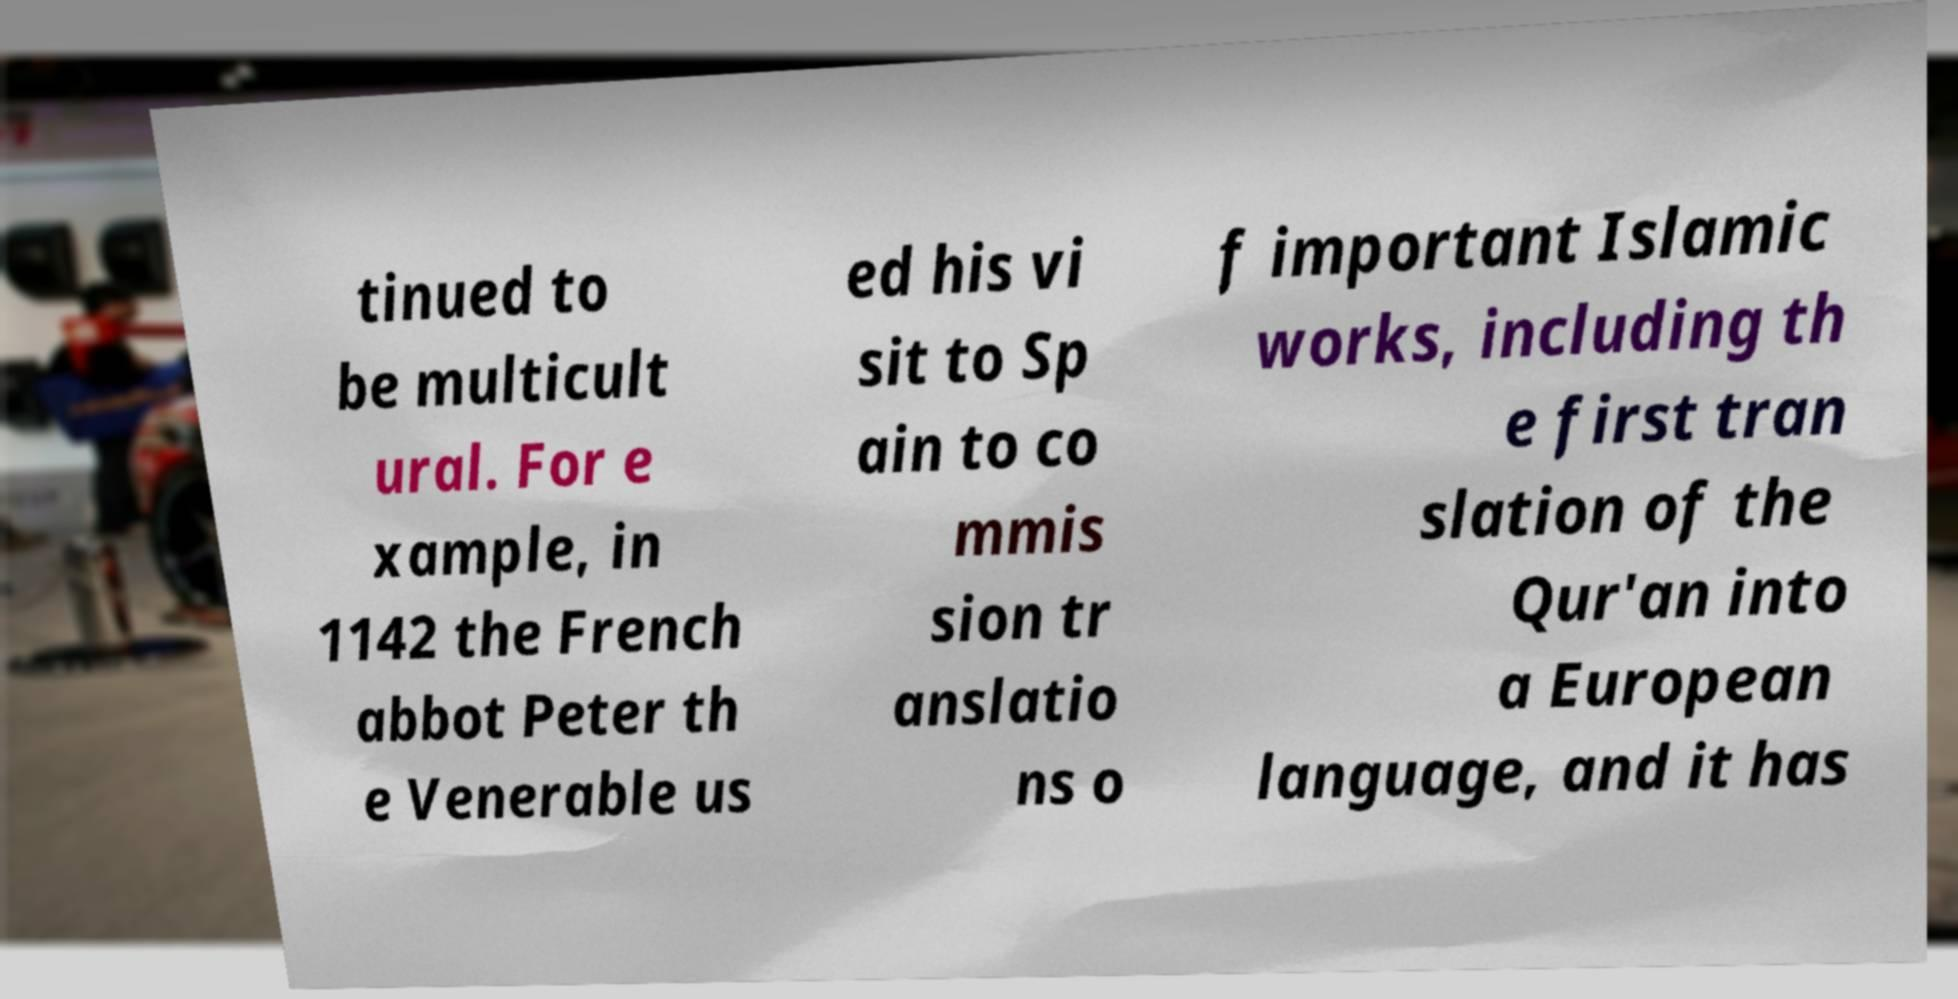I need the written content from this picture converted into text. Can you do that? tinued to be multicult ural. For e xample, in 1142 the French abbot Peter th e Venerable us ed his vi sit to Sp ain to co mmis sion tr anslatio ns o f important Islamic works, including th e first tran slation of the Qur'an into a European language, and it has 